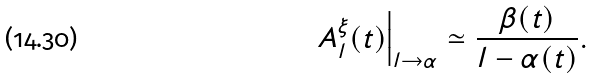Convert formula to latex. <formula><loc_0><loc_0><loc_500><loc_500>A _ { l } ^ { \xi } ( t ) \Big | _ { l \rightarrow \alpha } \simeq \frac { \beta ( t ) } { l - \alpha ( t ) } .</formula> 